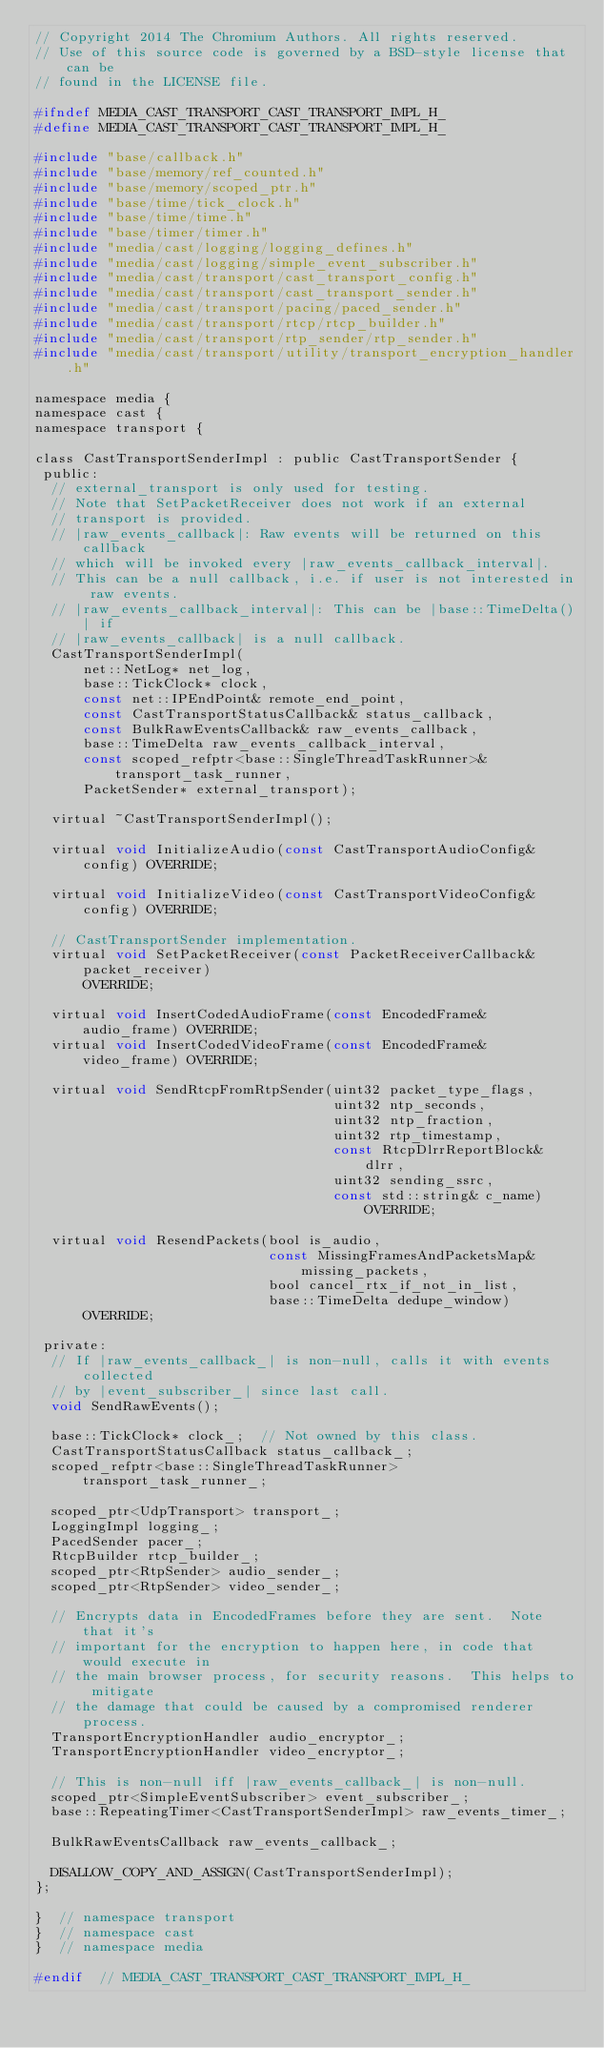Convert code to text. <code><loc_0><loc_0><loc_500><loc_500><_C_>// Copyright 2014 The Chromium Authors. All rights reserved.
// Use of this source code is governed by a BSD-style license that can be
// found in the LICENSE file.

#ifndef MEDIA_CAST_TRANSPORT_CAST_TRANSPORT_IMPL_H_
#define MEDIA_CAST_TRANSPORT_CAST_TRANSPORT_IMPL_H_

#include "base/callback.h"
#include "base/memory/ref_counted.h"
#include "base/memory/scoped_ptr.h"
#include "base/time/tick_clock.h"
#include "base/time/time.h"
#include "base/timer/timer.h"
#include "media/cast/logging/logging_defines.h"
#include "media/cast/logging/simple_event_subscriber.h"
#include "media/cast/transport/cast_transport_config.h"
#include "media/cast/transport/cast_transport_sender.h"
#include "media/cast/transport/pacing/paced_sender.h"
#include "media/cast/transport/rtcp/rtcp_builder.h"
#include "media/cast/transport/rtp_sender/rtp_sender.h"
#include "media/cast/transport/utility/transport_encryption_handler.h"

namespace media {
namespace cast {
namespace transport {

class CastTransportSenderImpl : public CastTransportSender {
 public:
  // external_transport is only used for testing.
  // Note that SetPacketReceiver does not work if an external
  // transport is provided.
  // |raw_events_callback|: Raw events will be returned on this callback
  // which will be invoked every |raw_events_callback_interval|.
  // This can be a null callback, i.e. if user is not interested in raw events.
  // |raw_events_callback_interval|: This can be |base::TimeDelta()| if
  // |raw_events_callback| is a null callback.
  CastTransportSenderImpl(
      net::NetLog* net_log,
      base::TickClock* clock,
      const net::IPEndPoint& remote_end_point,
      const CastTransportStatusCallback& status_callback,
      const BulkRawEventsCallback& raw_events_callback,
      base::TimeDelta raw_events_callback_interval,
      const scoped_refptr<base::SingleThreadTaskRunner>& transport_task_runner,
      PacketSender* external_transport);

  virtual ~CastTransportSenderImpl();

  virtual void InitializeAudio(const CastTransportAudioConfig& config) OVERRIDE;

  virtual void InitializeVideo(const CastTransportVideoConfig& config) OVERRIDE;

  // CastTransportSender implementation.
  virtual void SetPacketReceiver(const PacketReceiverCallback& packet_receiver)
      OVERRIDE;

  virtual void InsertCodedAudioFrame(const EncodedFrame& audio_frame) OVERRIDE;
  virtual void InsertCodedVideoFrame(const EncodedFrame& video_frame) OVERRIDE;

  virtual void SendRtcpFromRtpSender(uint32 packet_type_flags,
                                     uint32 ntp_seconds,
                                     uint32 ntp_fraction,
                                     uint32 rtp_timestamp,
                                     const RtcpDlrrReportBlock& dlrr,
                                     uint32 sending_ssrc,
                                     const std::string& c_name) OVERRIDE;

  virtual void ResendPackets(bool is_audio,
                             const MissingFramesAndPacketsMap& missing_packets,
                             bool cancel_rtx_if_not_in_list,
                             base::TimeDelta dedupe_window)
      OVERRIDE;

 private:
  // If |raw_events_callback_| is non-null, calls it with events collected
  // by |event_subscriber_| since last call.
  void SendRawEvents();

  base::TickClock* clock_;  // Not owned by this class.
  CastTransportStatusCallback status_callback_;
  scoped_refptr<base::SingleThreadTaskRunner> transport_task_runner_;

  scoped_ptr<UdpTransport> transport_;
  LoggingImpl logging_;
  PacedSender pacer_;
  RtcpBuilder rtcp_builder_;
  scoped_ptr<RtpSender> audio_sender_;
  scoped_ptr<RtpSender> video_sender_;

  // Encrypts data in EncodedFrames before they are sent.  Note that it's
  // important for the encryption to happen here, in code that would execute in
  // the main browser process, for security reasons.  This helps to mitigate
  // the damage that could be caused by a compromised renderer process.
  TransportEncryptionHandler audio_encryptor_;
  TransportEncryptionHandler video_encryptor_;

  // This is non-null iff |raw_events_callback_| is non-null.
  scoped_ptr<SimpleEventSubscriber> event_subscriber_;
  base::RepeatingTimer<CastTransportSenderImpl> raw_events_timer_;

  BulkRawEventsCallback raw_events_callback_;

  DISALLOW_COPY_AND_ASSIGN(CastTransportSenderImpl);
};

}  // namespace transport
}  // namespace cast
}  // namespace media

#endif  // MEDIA_CAST_TRANSPORT_CAST_TRANSPORT_IMPL_H_
</code> 